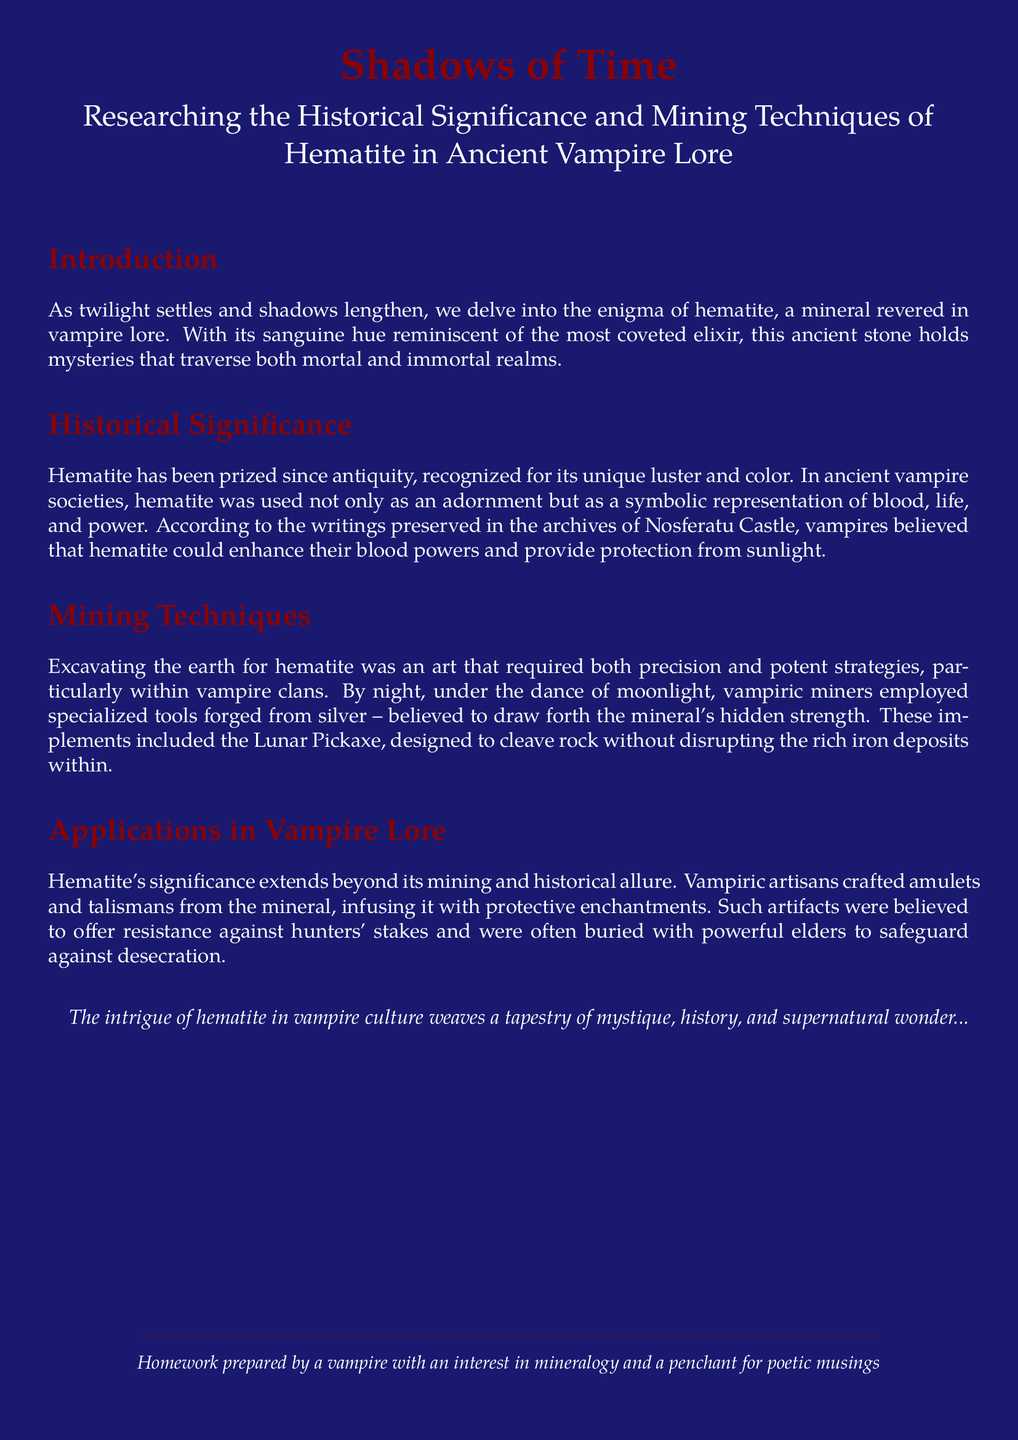What is the primary mineral discussed in the document? The document primarily discusses hematite, a mineral revered in vampire lore.
Answer: hematite What role did hematite play in ancient vampire societies? In ancient vampire societies, hematite was used as an adornment and symbolized blood, life, and power.
Answer: adornment, blood, life, power What specific artifact was crafted from hematite for protection? Vampiric artisans crafted amulets and talismans from hematite, believed to offer resistance against hunters' stakes.
Answer: amulets and talismans What tool was used by vampiric miners during hematite excavation? The Lunar Pickaxe was a specialized tool used by vampiric miners to cleave rock without disrupting iron deposits.
Answer: Lunar Pickaxe Which clan's archives contain writings about hematite? The archives preserved in Nosferatu Castle contain writings about hematite and its significance.
Answer: Nosferatu Castle Why was the Lunar Pickaxe considered special in mining? The Lunar Pickaxe was considered special as it was designed to cleave rock without disrupting the rich iron deposits within.
Answer: cleave rock without disrupting iron deposits What color is hematite described as in the document? Hematite is described as having a sanguine hue, reminiscent of the most coveted elixir.
Answer: sanguine hue How was hematite believed to affect vampires' powers? Vampires believed that hematite could enhance their blood powers and provide protection from sunlight.
Answer: enhance blood powers, protection from sunlight What is the theme of the introduction? The theme of the introduction revolves around the enigma of hematite and its connection to vampire lore.
Answer: enigma of hematite, vampire lore 